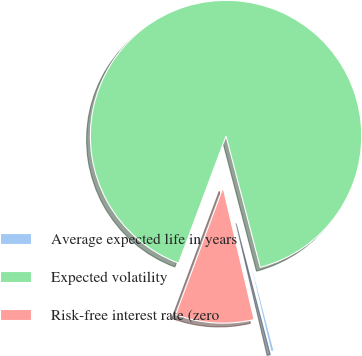<chart> <loc_0><loc_0><loc_500><loc_500><pie_chart><fcel>Average expected life in years<fcel>Expected volatility<fcel>Risk-free interest rate (zero<nl><fcel>0.38%<fcel>90.26%<fcel>9.36%<nl></chart> 